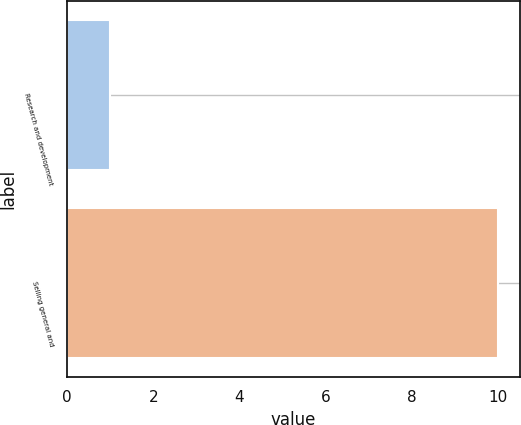Convert chart to OTSL. <chart><loc_0><loc_0><loc_500><loc_500><bar_chart><fcel>Research and development<fcel>Selling general and<nl><fcel>1<fcel>10<nl></chart> 